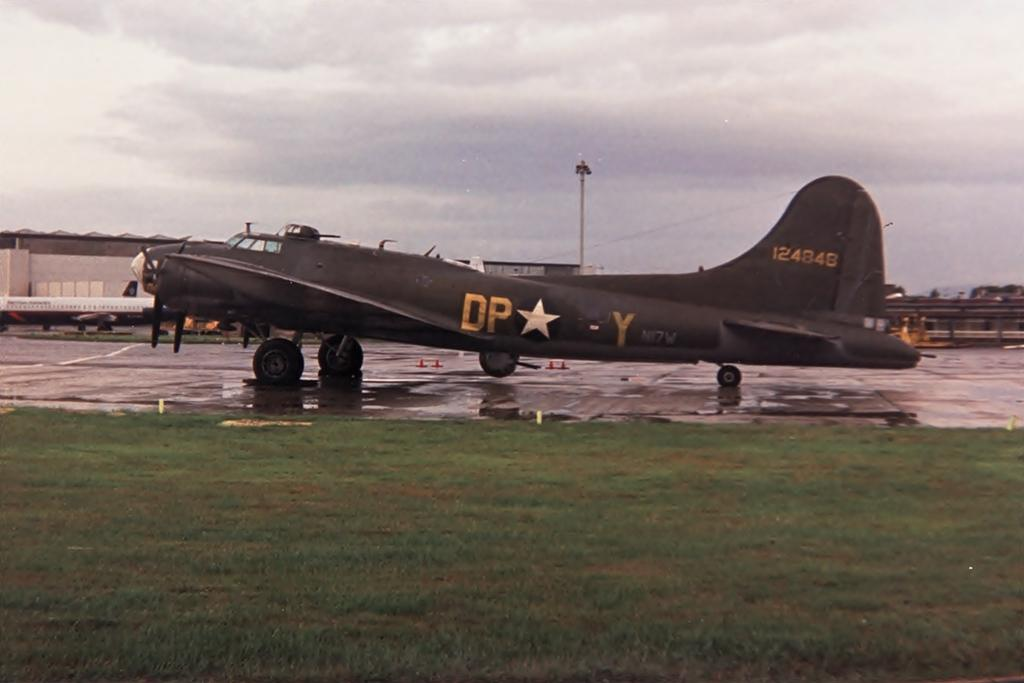Provide a one-sentence caption for the provided image. old us army dp- y plane sits on the runway. 